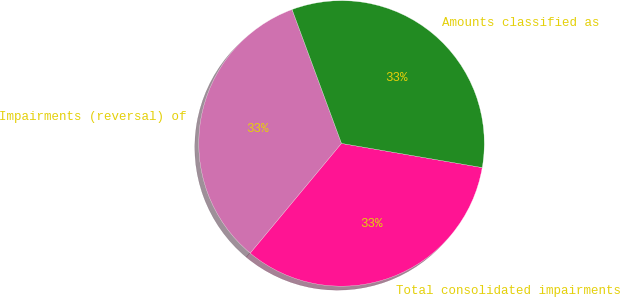Convert chart. <chart><loc_0><loc_0><loc_500><loc_500><pie_chart><fcel>Impairments (reversal) of<fcel>Total consolidated impairments<fcel>Amounts classified as<nl><fcel>33.33%<fcel>33.33%<fcel>33.33%<nl></chart> 